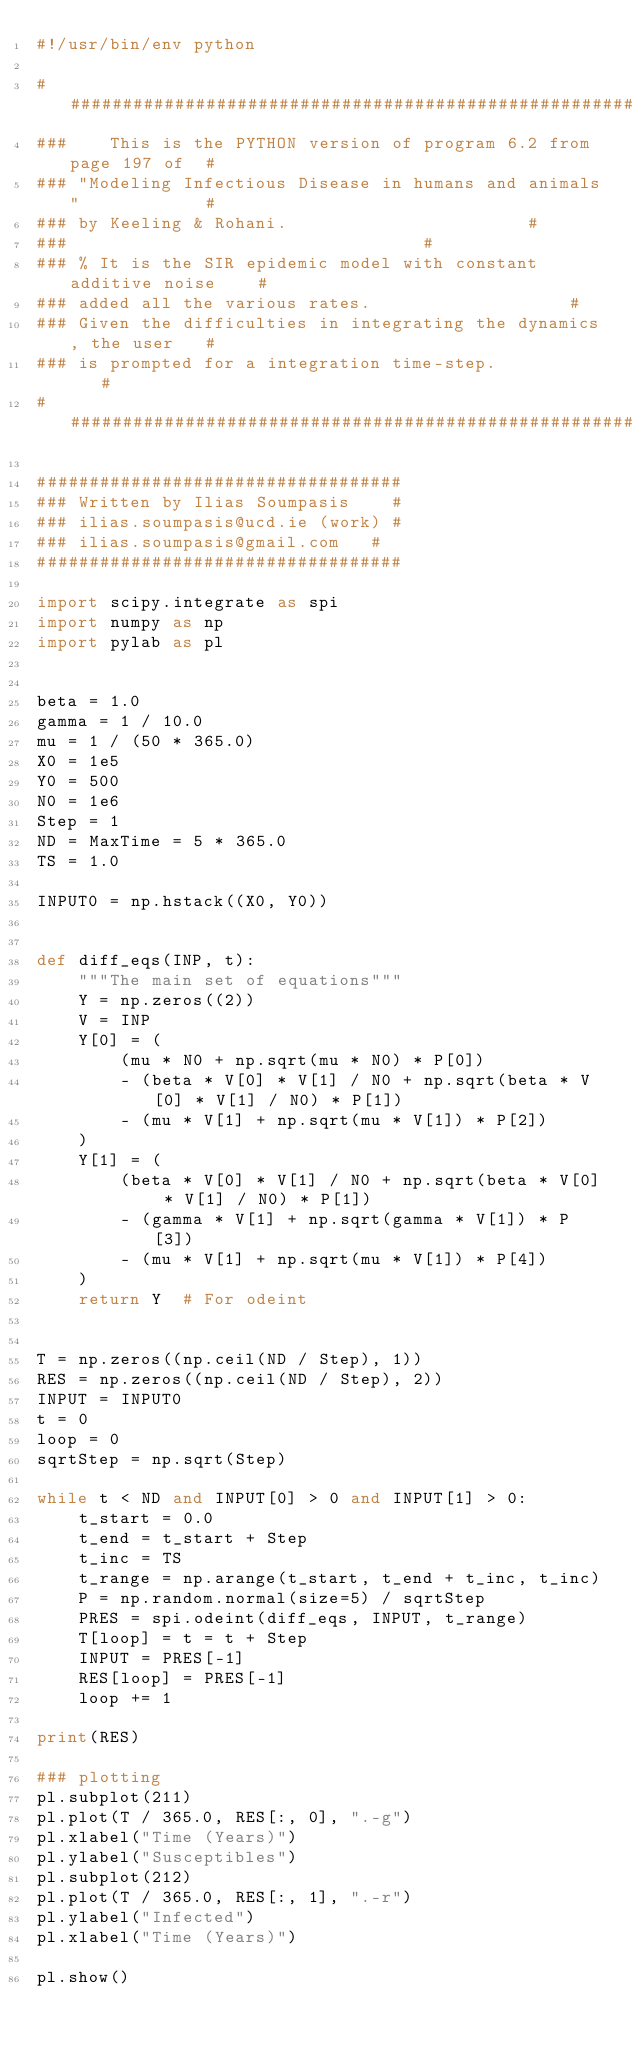Convert code to text. <code><loc_0><loc_0><loc_500><loc_500><_Python_>#!/usr/bin/env python

####################################################################
###    This is the PYTHON version of program 6.2 from page 197 of  #
### "Modeling Infectious Disease in humans and animals"            #
### by Keeling & Rohani.										   #
###																   #
### % It is the SIR epidemic model with constant additive noise    #
### added all the various rates.								   #
### Given the difficulties in integrating the dynamics, the user   #
### is prompted for a integration time-step.					   #
####################################################################

###################################
### Written by Ilias Soumpasis    #
### ilias.soumpasis@ucd.ie (work) #
### ilias.soumpasis@gmail.com	  #
###################################

import scipy.integrate as spi
import numpy as np
import pylab as pl


beta = 1.0
gamma = 1 / 10.0
mu = 1 / (50 * 365.0)
X0 = 1e5
Y0 = 500
N0 = 1e6
Step = 1
ND = MaxTime = 5 * 365.0
TS = 1.0

INPUT0 = np.hstack((X0, Y0))


def diff_eqs(INP, t):
    """The main set of equations"""
    Y = np.zeros((2))
    V = INP
    Y[0] = (
        (mu * N0 + np.sqrt(mu * N0) * P[0])
        - (beta * V[0] * V[1] / N0 + np.sqrt(beta * V[0] * V[1] / N0) * P[1])
        - (mu * V[1] + np.sqrt(mu * V[1]) * P[2])
    )
    Y[1] = (
        (beta * V[0] * V[1] / N0 + np.sqrt(beta * V[0] * V[1] / N0) * P[1])
        - (gamma * V[1] + np.sqrt(gamma * V[1]) * P[3])
        - (mu * V[1] + np.sqrt(mu * V[1]) * P[4])
    )
    return Y  # For odeint


T = np.zeros((np.ceil(ND / Step), 1))
RES = np.zeros((np.ceil(ND / Step), 2))
INPUT = INPUT0
t = 0
loop = 0
sqrtStep = np.sqrt(Step)

while t < ND and INPUT[0] > 0 and INPUT[1] > 0:
    t_start = 0.0
    t_end = t_start + Step
    t_inc = TS
    t_range = np.arange(t_start, t_end + t_inc, t_inc)
    P = np.random.normal(size=5) / sqrtStep
    PRES = spi.odeint(diff_eqs, INPUT, t_range)
    T[loop] = t = t + Step
    INPUT = PRES[-1]
    RES[loop] = PRES[-1]
    loop += 1

print(RES)

### plotting
pl.subplot(211)
pl.plot(T / 365.0, RES[:, 0], ".-g")
pl.xlabel("Time (Years)")
pl.ylabel("Susceptibles")
pl.subplot(212)
pl.plot(T / 365.0, RES[:, 1], ".-r")
pl.ylabel("Infected")
pl.xlabel("Time (Years)")

pl.show()
</code> 